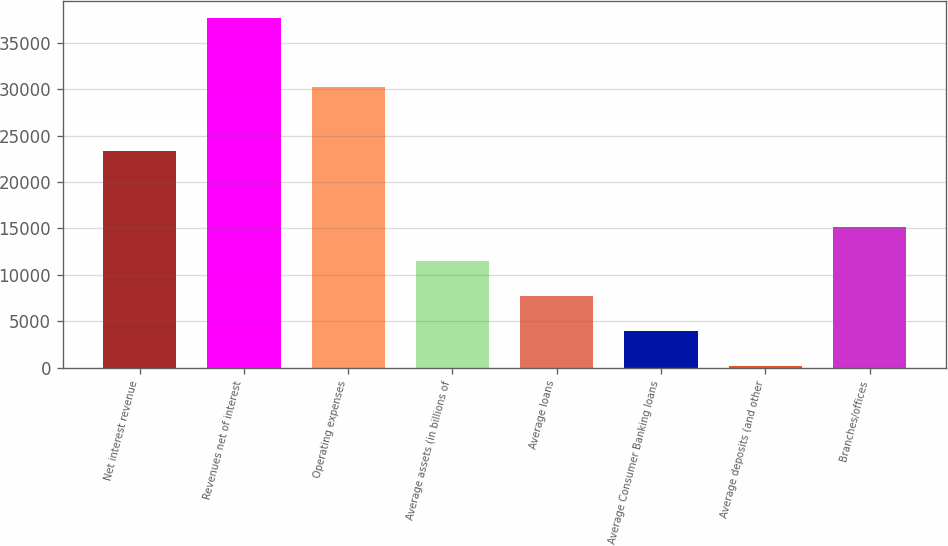<chart> <loc_0><loc_0><loc_500><loc_500><bar_chart><fcel>Net interest revenue<fcel>Revenues net of interest<fcel>Operating expenses<fcel>Average assets (in billions of<fcel>Average loans<fcel>Average Consumer Banking loans<fcel>Average deposits (and other<fcel>Branches/offices<nl><fcel>23333<fcel>37634<fcel>30186<fcel>11461.8<fcel>7722.88<fcel>3983.99<fcel>245.1<fcel>15200.7<nl></chart> 